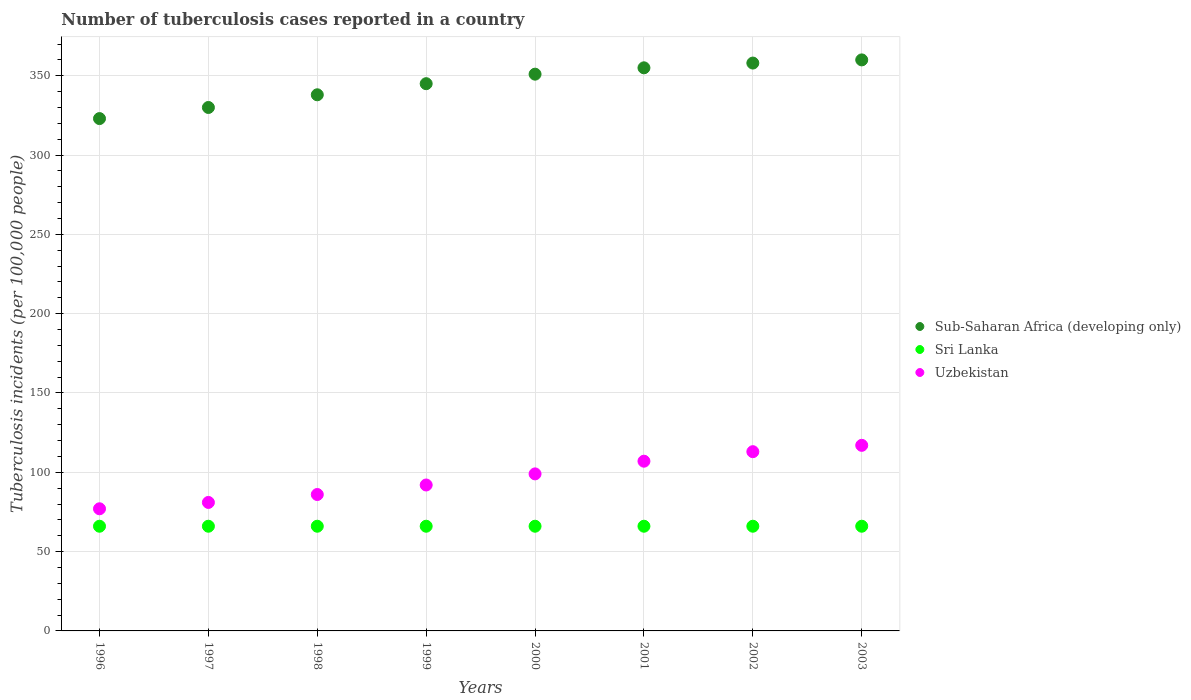How many different coloured dotlines are there?
Your response must be concise. 3. What is the number of tuberculosis cases reported in in Sub-Saharan Africa (developing only) in 2003?
Ensure brevity in your answer.  360. Across all years, what is the maximum number of tuberculosis cases reported in in Uzbekistan?
Provide a short and direct response. 117. Across all years, what is the minimum number of tuberculosis cases reported in in Uzbekistan?
Provide a short and direct response. 77. In which year was the number of tuberculosis cases reported in in Sri Lanka maximum?
Your answer should be compact. 1996. In which year was the number of tuberculosis cases reported in in Sub-Saharan Africa (developing only) minimum?
Offer a very short reply. 1996. What is the total number of tuberculosis cases reported in in Sub-Saharan Africa (developing only) in the graph?
Your answer should be very brief. 2760. What is the difference between the number of tuberculosis cases reported in in Uzbekistan in 1997 and the number of tuberculosis cases reported in in Sri Lanka in 2000?
Ensure brevity in your answer.  15. What is the average number of tuberculosis cases reported in in Sub-Saharan Africa (developing only) per year?
Offer a terse response. 345. In the year 1999, what is the difference between the number of tuberculosis cases reported in in Uzbekistan and number of tuberculosis cases reported in in Sri Lanka?
Give a very brief answer. 26. In how many years, is the number of tuberculosis cases reported in in Uzbekistan greater than 230?
Provide a succinct answer. 0. Is the number of tuberculosis cases reported in in Sri Lanka in 1997 less than that in 2001?
Provide a short and direct response. No. Is the difference between the number of tuberculosis cases reported in in Uzbekistan in 2001 and 2003 greater than the difference between the number of tuberculosis cases reported in in Sri Lanka in 2001 and 2003?
Offer a very short reply. No. What is the difference between the highest and the lowest number of tuberculosis cases reported in in Sub-Saharan Africa (developing only)?
Your answer should be compact. 37. In how many years, is the number of tuberculosis cases reported in in Sri Lanka greater than the average number of tuberculosis cases reported in in Sri Lanka taken over all years?
Your answer should be very brief. 0. Is the sum of the number of tuberculosis cases reported in in Sri Lanka in 1998 and 2000 greater than the maximum number of tuberculosis cases reported in in Uzbekistan across all years?
Provide a short and direct response. Yes. Is it the case that in every year, the sum of the number of tuberculosis cases reported in in Sub-Saharan Africa (developing only) and number of tuberculosis cases reported in in Sri Lanka  is greater than the number of tuberculosis cases reported in in Uzbekistan?
Offer a very short reply. Yes. Is the number of tuberculosis cases reported in in Sub-Saharan Africa (developing only) strictly greater than the number of tuberculosis cases reported in in Uzbekistan over the years?
Provide a succinct answer. Yes. Is the number of tuberculosis cases reported in in Sri Lanka strictly less than the number of tuberculosis cases reported in in Uzbekistan over the years?
Your response must be concise. Yes. How many years are there in the graph?
Ensure brevity in your answer.  8. Does the graph contain any zero values?
Your response must be concise. No. Does the graph contain grids?
Offer a terse response. Yes. How many legend labels are there?
Your answer should be very brief. 3. What is the title of the graph?
Offer a terse response. Number of tuberculosis cases reported in a country. What is the label or title of the Y-axis?
Your response must be concise. Tuberculosis incidents (per 100,0 people). What is the Tuberculosis incidents (per 100,000 people) in Sub-Saharan Africa (developing only) in 1996?
Keep it short and to the point. 323. What is the Tuberculosis incidents (per 100,000 people) in Sri Lanka in 1996?
Your response must be concise. 66. What is the Tuberculosis incidents (per 100,000 people) in Sub-Saharan Africa (developing only) in 1997?
Offer a terse response. 330. What is the Tuberculosis incidents (per 100,000 people) in Sri Lanka in 1997?
Provide a short and direct response. 66. What is the Tuberculosis incidents (per 100,000 people) in Sub-Saharan Africa (developing only) in 1998?
Keep it short and to the point. 338. What is the Tuberculosis incidents (per 100,000 people) of Sri Lanka in 1998?
Ensure brevity in your answer.  66. What is the Tuberculosis incidents (per 100,000 people) in Sub-Saharan Africa (developing only) in 1999?
Give a very brief answer. 345. What is the Tuberculosis incidents (per 100,000 people) of Sri Lanka in 1999?
Offer a very short reply. 66. What is the Tuberculosis incidents (per 100,000 people) of Uzbekistan in 1999?
Your answer should be compact. 92. What is the Tuberculosis incidents (per 100,000 people) of Sub-Saharan Africa (developing only) in 2000?
Offer a very short reply. 351. What is the Tuberculosis incidents (per 100,000 people) of Uzbekistan in 2000?
Your answer should be very brief. 99. What is the Tuberculosis incidents (per 100,000 people) of Sub-Saharan Africa (developing only) in 2001?
Give a very brief answer. 355. What is the Tuberculosis incidents (per 100,000 people) of Sri Lanka in 2001?
Provide a succinct answer. 66. What is the Tuberculosis incidents (per 100,000 people) in Uzbekistan in 2001?
Provide a short and direct response. 107. What is the Tuberculosis incidents (per 100,000 people) in Sub-Saharan Africa (developing only) in 2002?
Offer a terse response. 358. What is the Tuberculosis incidents (per 100,000 people) of Sri Lanka in 2002?
Ensure brevity in your answer.  66. What is the Tuberculosis incidents (per 100,000 people) of Uzbekistan in 2002?
Ensure brevity in your answer.  113. What is the Tuberculosis incidents (per 100,000 people) of Sub-Saharan Africa (developing only) in 2003?
Your answer should be compact. 360. What is the Tuberculosis incidents (per 100,000 people) in Uzbekistan in 2003?
Keep it short and to the point. 117. Across all years, what is the maximum Tuberculosis incidents (per 100,000 people) in Sub-Saharan Africa (developing only)?
Give a very brief answer. 360. Across all years, what is the maximum Tuberculosis incidents (per 100,000 people) of Uzbekistan?
Your answer should be very brief. 117. Across all years, what is the minimum Tuberculosis incidents (per 100,000 people) of Sub-Saharan Africa (developing only)?
Provide a succinct answer. 323. What is the total Tuberculosis incidents (per 100,000 people) in Sub-Saharan Africa (developing only) in the graph?
Offer a very short reply. 2760. What is the total Tuberculosis incidents (per 100,000 people) of Sri Lanka in the graph?
Ensure brevity in your answer.  528. What is the total Tuberculosis incidents (per 100,000 people) in Uzbekistan in the graph?
Your answer should be very brief. 772. What is the difference between the Tuberculosis incidents (per 100,000 people) in Uzbekistan in 1996 and that in 1997?
Your response must be concise. -4. What is the difference between the Tuberculosis incidents (per 100,000 people) of Sub-Saharan Africa (developing only) in 1996 and that in 1998?
Offer a very short reply. -15. What is the difference between the Tuberculosis incidents (per 100,000 people) of Sub-Saharan Africa (developing only) in 1996 and that in 1999?
Offer a very short reply. -22. What is the difference between the Tuberculosis incidents (per 100,000 people) of Uzbekistan in 1996 and that in 1999?
Your response must be concise. -15. What is the difference between the Tuberculosis incidents (per 100,000 people) of Sub-Saharan Africa (developing only) in 1996 and that in 2000?
Provide a short and direct response. -28. What is the difference between the Tuberculosis incidents (per 100,000 people) in Sri Lanka in 1996 and that in 2000?
Your response must be concise. 0. What is the difference between the Tuberculosis incidents (per 100,000 people) of Sub-Saharan Africa (developing only) in 1996 and that in 2001?
Provide a short and direct response. -32. What is the difference between the Tuberculosis incidents (per 100,000 people) in Sub-Saharan Africa (developing only) in 1996 and that in 2002?
Your answer should be very brief. -35. What is the difference between the Tuberculosis incidents (per 100,000 people) in Uzbekistan in 1996 and that in 2002?
Ensure brevity in your answer.  -36. What is the difference between the Tuberculosis incidents (per 100,000 people) of Sub-Saharan Africa (developing only) in 1996 and that in 2003?
Your answer should be compact. -37. What is the difference between the Tuberculosis incidents (per 100,000 people) of Sri Lanka in 1996 and that in 2003?
Your answer should be compact. 0. What is the difference between the Tuberculosis incidents (per 100,000 people) of Sub-Saharan Africa (developing only) in 1997 and that in 1998?
Your answer should be compact. -8. What is the difference between the Tuberculosis incidents (per 100,000 people) in Sri Lanka in 1997 and that in 1998?
Ensure brevity in your answer.  0. What is the difference between the Tuberculosis incidents (per 100,000 people) in Uzbekistan in 1997 and that in 1998?
Offer a very short reply. -5. What is the difference between the Tuberculosis incidents (per 100,000 people) in Sub-Saharan Africa (developing only) in 1997 and that in 1999?
Your response must be concise. -15. What is the difference between the Tuberculosis incidents (per 100,000 people) in Sri Lanka in 1997 and that in 1999?
Your answer should be compact. 0. What is the difference between the Tuberculosis incidents (per 100,000 people) of Uzbekistan in 1997 and that in 1999?
Provide a succinct answer. -11. What is the difference between the Tuberculosis incidents (per 100,000 people) of Sri Lanka in 1997 and that in 2000?
Give a very brief answer. 0. What is the difference between the Tuberculosis incidents (per 100,000 people) of Uzbekistan in 1997 and that in 2000?
Give a very brief answer. -18. What is the difference between the Tuberculosis incidents (per 100,000 people) of Sub-Saharan Africa (developing only) in 1997 and that in 2001?
Ensure brevity in your answer.  -25. What is the difference between the Tuberculosis incidents (per 100,000 people) in Sri Lanka in 1997 and that in 2001?
Provide a short and direct response. 0. What is the difference between the Tuberculosis incidents (per 100,000 people) in Sri Lanka in 1997 and that in 2002?
Make the answer very short. 0. What is the difference between the Tuberculosis incidents (per 100,000 people) in Uzbekistan in 1997 and that in 2002?
Provide a short and direct response. -32. What is the difference between the Tuberculosis incidents (per 100,000 people) of Sri Lanka in 1997 and that in 2003?
Make the answer very short. 0. What is the difference between the Tuberculosis incidents (per 100,000 people) in Uzbekistan in 1997 and that in 2003?
Your answer should be very brief. -36. What is the difference between the Tuberculosis incidents (per 100,000 people) in Sub-Saharan Africa (developing only) in 1998 and that in 1999?
Make the answer very short. -7. What is the difference between the Tuberculosis incidents (per 100,000 people) of Sri Lanka in 1998 and that in 1999?
Offer a terse response. 0. What is the difference between the Tuberculosis incidents (per 100,000 people) in Sub-Saharan Africa (developing only) in 1998 and that in 2000?
Offer a very short reply. -13. What is the difference between the Tuberculosis incidents (per 100,000 people) of Uzbekistan in 1998 and that in 2000?
Your response must be concise. -13. What is the difference between the Tuberculosis incidents (per 100,000 people) in Sub-Saharan Africa (developing only) in 1998 and that in 2001?
Offer a very short reply. -17. What is the difference between the Tuberculosis incidents (per 100,000 people) of Sri Lanka in 1998 and that in 2001?
Your response must be concise. 0. What is the difference between the Tuberculosis incidents (per 100,000 people) of Sub-Saharan Africa (developing only) in 1998 and that in 2002?
Offer a terse response. -20. What is the difference between the Tuberculosis incidents (per 100,000 people) in Uzbekistan in 1998 and that in 2002?
Provide a short and direct response. -27. What is the difference between the Tuberculosis incidents (per 100,000 people) in Sri Lanka in 1998 and that in 2003?
Offer a very short reply. 0. What is the difference between the Tuberculosis incidents (per 100,000 people) of Uzbekistan in 1998 and that in 2003?
Keep it short and to the point. -31. What is the difference between the Tuberculosis incidents (per 100,000 people) in Sub-Saharan Africa (developing only) in 1999 and that in 2000?
Offer a terse response. -6. What is the difference between the Tuberculosis incidents (per 100,000 people) of Uzbekistan in 1999 and that in 2002?
Your answer should be very brief. -21. What is the difference between the Tuberculosis incidents (per 100,000 people) in Sri Lanka in 1999 and that in 2003?
Your answer should be compact. 0. What is the difference between the Tuberculosis incidents (per 100,000 people) in Sub-Saharan Africa (developing only) in 2000 and that in 2001?
Give a very brief answer. -4. What is the difference between the Tuberculosis incidents (per 100,000 people) of Sub-Saharan Africa (developing only) in 2000 and that in 2002?
Keep it short and to the point. -7. What is the difference between the Tuberculosis incidents (per 100,000 people) in Uzbekistan in 2000 and that in 2002?
Your answer should be compact. -14. What is the difference between the Tuberculosis incidents (per 100,000 people) of Uzbekistan in 2000 and that in 2003?
Ensure brevity in your answer.  -18. What is the difference between the Tuberculosis incidents (per 100,000 people) in Sub-Saharan Africa (developing only) in 2001 and that in 2002?
Your answer should be compact. -3. What is the difference between the Tuberculosis incidents (per 100,000 people) of Sri Lanka in 2001 and that in 2002?
Your response must be concise. 0. What is the difference between the Tuberculosis incidents (per 100,000 people) in Sri Lanka in 2001 and that in 2003?
Ensure brevity in your answer.  0. What is the difference between the Tuberculosis incidents (per 100,000 people) in Uzbekistan in 2001 and that in 2003?
Your answer should be compact. -10. What is the difference between the Tuberculosis incidents (per 100,000 people) in Sub-Saharan Africa (developing only) in 1996 and the Tuberculosis incidents (per 100,000 people) in Sri Lanka in 1997?
Your answer should be very brief. 257. What is the difference between the Tuberculosis incidents (per 100,000 people) in Sub-Saharan Africa (developing only) in 1996 and the Tuberculosis incidents (per 100,000 people) in Uzbekistan in 1997?
Offer a terse response. 242. What is the difference between the Tuberculosis incidents (per 100,000 people) of Sri Lanka in 1996 and the Tuberculosis incidents (per 100,000 people) of Uzbekistan in 1997?
Keep it short and to the point. -15. What is the difference between the Tuberculosis incidents (per 100,000 people) in Sub-Saharan Africa (developing only) in 1996 and the Tuberculosis incidents (per 100,000 people) in Sri Lanka in 1998?
Offer a very short reply. 257. What is the difference between the Tuberculosis incidents (per 100,000 people) in Sub-Saharan Africa (developing only) in 1996 and the Tuberculosis incidents (per 100,000 people) in Uzbekistan in 1998?
Your response must be concise. 237. What is the difference between the Tuberculosis incidents (per 100,000 people) in Sub-Saharan Africa (developing only) in 1996 and the Tuberculosis incidents (per 100,000 people) in Sri Lanka in 1999?
Offer a terse response. 257. What is the difference between the Tuberculosis incidents (per 100,000 people) of Sub-Saharan Africa (developing only) in 1996 and the Tuberculosis incidents (per 100,000 people) of Uzbekistan in 1999?
Your answer should be very brief. 231. What is the difference between the Tuberculosis incidents (per 100,000 people) of Sub-Saharan Africa (developing only) in 1996 and the Tuberculosis incidents (per 100,000 people) of Sri Lanka in 2000?
Your answer should be compact. 257. What is the difference between the Tuberculosis incidents (per 100,000 people) of Sub-Saharan Africa (developing only) in 1996 and the Tuberculosis incidents (per 100,000 people) of Uzbekistan in 2000?
Your response must be concise. 224. What is the difference between the Tuberculosis incidents (per 100,000 people) of Sri Lanka in 1996 and the Tuberculosis incidents (per 100,000 people) of Uzbekistan in 2000?
Offer a very short reply. -33. What is the difference between the Tuberculosis incidents (per 100,000 people) in Sub-Saharan Africa (developing only) in 1996 and the Tuberculosis incidents (per 100,000 people) in Sri Lanka in 2001?
Ensure brevity in your answer.  257. What is the difference between the Tuberculosis incidents (per 100,000 people) in Sub-Saharan Africa (developing only) in 1996 and the Tuberculosis incidents (per 100,000 people) in Uzbekistan in 2001?
Provide a succinct answer. 216. What is the difference between the Tuberculosis incidents (per 100,000 people) of Sri Lanka in 1996 and the Tuberculosis incidents (per 100,000 people) of Uzbekistan in 2001?
Offer a terse response. -41. What is the difference between the Tuberculosis incidents (per 100,000 people) of Sub-Saharan Africa (developing only) in 1996 and the Tuberculosis incidents (per 100,000 people) of Sri Lanka in 2002?
Provide a succinct answer. 257. What is the difference between the Tuberculosis incidents (per 100,000 people) of Sub-Saharan Africa (developing only) in 1996 and the Tuberculosis incidents (per 100,000 people) of Uzbekistan in 2002?
Your answer should be compact. 210. What is the difference between the Tuberculosis incidents (per 100,000 people) in Sri Lanka in 1996 and the Tuberculosis incidents (per 100,000 people) in Uzbekistan in 2002?
Give a very brief answer. -47. What is the difference between the Tuberculosis incidents (per 100,000 people) of Sub-Saharan Africa (developing only) in 1996 and the Tuberculosis incidents (per 100,000 people) of Sri Lanka in 2003?
Offer a very short reply. 257. What is the difference between the Tuberculosis incidents (per 100,000 people) of Sub-Saharan Africa (developing only) in 1996 and the Tuberculosis incidents (per 100,000 people) of Uzbekistan in 2003?
Give a very brief answer. 206. What is the difference between the Tuberculosis incidents (per 100,000 people) of Sri Lanka in 1996 and the Tuberculosis incidents (per 100,000 people) of Uzbekistan in 2003?
Your answer should be very brief. -51. What is the difference between the Tuberculosis incidents (per 100,000 people) in Sub-Saharan Africa (developing only) in 1997 and the Tuberculosis incidents (per 100,000 people) in Sri Lanka in 1998?
Ensure brevity in your answer.  264. What is the difference between the Tuberculosis incidents (per 100,000 people) of Sub-Saharan Africa (developing only) in 1997 and the Tuberculosis incidents (per 100,000 people) of Uzbekistan in 1998?
Keep it short and to the point. 244. What is the difference between the Tuberculosis incidents (per 100,000 people) of Sri Lanka in 1997 and the Tuberculosis incidents (per 100,000 people) of Uzbekistan in 1998?
Offer a very short reply. -20. What is the difference between the Tuberculosis incidents (per 100,000 people) of Sub-Saharan Africa (developing only) in 1997 and the Tuberculosis incidents (per 100,000 people) of Sri Lanka in 1999?
Provide a succinct answer. 264. What is the difference between the Tuberculosis incidents (per 100,000 people) of Sub-Saharan Africa (developing only) in 1997 and the Tuberculosis incidents (per 100,000 people) of Uzbekistan in 1999?
Offer a terse response. 238. What is the difference between the Tuberculosis incidents (per 100,000 people) of Sub-Saharan Africa (developing only) in 1997 and the Tuberculosis incidents (per 100,000 people) of Sri Lanka in 2000?
Your answer should be compact. 264. What is the difference between the Tuberculosis incidents (per 100,000 people) in Sub-Saharan Africa (developing only) in 1997 and the Tuberculosis incidents (per 100,000 people) in Uzbekistan in 2000?
Make the answer very short. 231. What is the difference between the Tuberculosis incidents (per 100,000 people) of Sri Lanka in 1997 and the Tuberculosis incidents (per 100,000 people) of Uzbekistan in 2000?
Give a very brief answer. -33. What is the difference between the Tuberculosis incidents (per 100,000 people) of Sub-Saharan Africa (developing only) in 1997 and the Tuberculosis incidents (per 100,000 people) of Sri Lanka in 2001?
Your answer should be compact. 264. What is the difference between the Tuberculosis incidents (per 100,000 people) in Sub-Saharan Africa (developing only) in 1997 and the Tuberculosis incidents (per 100,000 people) in Uzbekistan in 2001?
Provide a succinct answer. 223. What is the difference between the Tuberculosis incidents (per 100,000 people) of Sri Lanka in 1997 and the Tuberculosis incidents (per 100,000 people) of Uzbekistan in 2001?
Keep it short and to the point. -41. What is the difference between the Tuberculosis incidents (per 100,000 people) in Sub-Saharan Africa (developing only) in 1997 and the Tuberculosis incidents (per 100,000 people) in Sri Lanka in 2002?
Provide a succinct answer. 264. What is the difference between the Tuberculosis incidents (per 100,000 people) in Sub-Saharan Africa (developing only) in 1997 and the Tuberculosis incidents (per 100,000 people) in Uzbekistan in 2002?
Give a very brief answer. 217. What is the difference between the Tuberculosis incidents (per 100,000 people) in Sri Lanka in 1997 and the Tuberculosis incidents (per 100,000 people) in Uzbekistan in 2002?
Your answer should be very brief. -47. What is the difference between the Tuberculosis incidents (per 100,000 people) of Sub-Saharan Africa (developing only) in 1997 and the Tuberculosis incidents (per 100,000 people) of Sri Lanka in 2003?
Your answer should be compact. 264. What is the difference between the Tuberculosis incidents (per 100,000 people) in Sub-Saharan Africa (developing only) in 1997 and the Tuberculosis incidents (per 100,000 people) in Uzbekistan in 2003?
Ensure brevity in your answer.  213. What is the difference between the Tuberculosis incidents (per 100,000 people) of Sri Lanka in 1997 and the Tuberculosis incidents (per 100,000 people) of Uzbekistan in 2003?
Give a very brief answer. -51. What is the difference between the Tuberculosis incidents (per 100,000 people) in Sub-Saharan Africa (developing only) in 1998 and the Tuberculosis incidents (per 100,000 people) in Sri Lanka in 1999?
Your answer should be very brief. 272. What is the difference between the Tuberculosis incidents (per 100,000 people) in Sub-Saharan Africa (developing only) in 1998 and the Tuberculosis incidents (per 100,000 people) in Uzbekistan in 1999?
Your answer should be very brief. 246. What is the difference between the Tuberculosis incidents (per 100,000 people) of Sri Lanka in 1998 and the Tuberculosis incidents (per 100,000 people) of Uzbekistan in 1999?
Provide a short and direct response. -26. What is the difference between the Tuberculosis incidents (per 100,000 people) of Sub-Saharan Africa (developing only) in 1998 and the Tuberculosis incidents (per 100,000 people) of Sri Lanka in 2000?
Give a very brief answer. 272. What is the difference between the Tuberculosis incidents (per 100,000 people) in Sub-Saharan Africa (developing only) in 1998 and the Tuberculosis incidents (per 100,000 people) in Uzbekistan in 2000?
Your answer should be compact. 239. What is the difference between the Tuberculosis incidents (per 100,000 people) in Sri Lanka in 1998 and the Tuberculosis incidents (per 100,000 people) in Uzbekistan in 2000?
Your answer should be very brief. -33. What is the difference between the Tuberculosis incidents (per 100,000 people) in Sub-Saharan Africa (developing only) in 1998 and the Tuberculosis incidents (per 100,000 people) in Sri Lanka in 2001?
Give a very brief answer. 272. What is the difference between the Tuberculosis incidents (per 100,000 people) in Sub-Saharan Africa (developing only) in 1998 and the Tuberculosis incidents (per 100,000 people) in Uzbekistan in 2001?
Offer a terse response. 231. What is the difference between the Tuberculosis incidents (per 100,000 people) of Sri Lanka in 1998 and the Tuberculosis incidents (per 100,000 people) of Uzbekistan in 2001?
Your response must be concise. -41. What is the difference between the Tuberculosis incidents (per 100,000 people) of Sub-Saharan Africa (developing only) in 1998 and the Tuberculosis incidents (per 100,000 people) of Sri Lanka in 2002?
Your response must be concise. 272. What is the difference between the Tuberculosis incidents (per 100,000 people) in Sub-Saharan Africa (developing only) in 1998 and the Tuberculosis incidents (per 100,000 people) in Uzbekistan in 2002?
Your answer should be very brief. 225. What is the difference between the Tuberculosis incidents (per 100,000 people) in Sri Lanka in 1998 and the Tuberculosis incidents (per 100,000 people) in Uzbekistan in 2002?
Provide a short and direct response. -47. What is the difference between the Tuberculosis incidents (per 100,000 people) in Sub-Saharan Africa (developing only) in 1998 and the Tuberculosis incidents (per 100,000 people) in Sri Lanka in 2003?
Provide a short and direct response. 272. What is the difference between the Tuberculosis incidents (per 100,000 people) in Sub-Saharan Africa (developing only) in 1998 and the Tuberculosis incidents (per 100,000 people) in Uzbekistan in 2003?
Give a very brief answer. 221. What is the difference between the Tuberculosis incidents (per 100,000 people) in Sri Lanka in 1998 and the Tuberculosis incidents (per 100,000 people) in Uzbekistan in 2003?
Your response must be concise. -51. What is the difference between the Tuberculosis incidents (per 100,000 people) in Sub-Saharan Africa (developing only) in 1999 and the Tuberculosis incidents (per 100,000 people) in Sri Lanka in 2000?
Offer a terse response. 279. What is the difference between the Tuberculosis incidents (per 100,000 people) in Sub-Saharan Africa (developing only) in 1999 and the Tuberculosis incidents (per 100,000 people) in Uzbekistan in 2000?
Your answer should be very brief. 246. What is the difference between the Tuberculosis incidents (per 100,000 people) in Sri Lanka in 1999 and the Tuberculosis incidents (per 100,000 people) in Uzbekistan in 2000?
Ensure brevity in your answer.  -33. What is the difference between the Tuberculosis incidents (per 100,000 people) of Sub-Saharan Africa (developing only) in 1999 and the Tuberculosis incidents (per 100,000 people) of Sri Lanka in 2001?
Your response must be concise. 279. What is the difference between the Tuberculosis incidents (per 100,000 people) of Sub-Saharan Africa (developing only) in 1999 and the Tuberculosis incidents (per 100,000 people) of Uzbekistan in 2001?
Ensure brevity in your answer.  238. What is the difference between the Tuberculosis incidents (per 100,000 people) of Sri Lanka in 1999 and the Tuberculosis incidents (per 100,000 people) of Uzbekistan in 2001?
Your response must be concise. -41. What is the difference between the Tuberculosis incidents (per 100,000 people) in Sub-Saharan Africa (developing only) in 1999 and the Tuberculosis incidents (per 100,000 people) in Sri Lanka in 2002?
Ensure brevity in your answer.  279. What is the difference between the Tuberculosis incidents (per 100,000 people) of Sub-Saharan Africa (developing only) in 1999 and the Tuberculosis incidents (per 100,000 people) of Uzbekistan in 2002?
Your answer should be very brief. 232. What is the difference between the Tuberculosis incidents (per 100,000 people) in Sri Lanka in 1999 and the Tuberculosis incidents (per 100,000 people) in Uzbekistan in 2002?
Offer a very short reply. -47. What is the difference between the Tuberculosis incidents (per 100,000 people) in Sub-Saharan Africa (developing only) in 1999 and the Tuberculosis incidents (per 100,000 people) in Sri Lanka in 2003?
Your answer should be very brief. 279. What is the difference between the Tuberculosis incidents (per 100,000 people) of Sub-Saharan Africa (developing only) in 1999 and the Tuberculosis incidents (per 100,000 people) of Uzbekistan in 2003?
Give a very brief answer. 228. What is the difference between the Tuberculosis incidents (per 100,000 people) in Sri Lanka in 1999 and the Tuberculosis incidents (per 100,000 people) in Uzbekistan in 2003?
Give a very brief answer. -51. What is the difference between the Tuberculosis incidents (per 100,000 people) of Sub-Saharan Africa (developing only) in 2000 and the Tuberculosis incidents (per 100,000 people) of Sri Lanka in 2001?
Offer a terse response. 285. What is the difference between the Tuberculosis incidents (per 100,000 people) in Sub-Saharan Africa (developing only) in 2000 and the Tuberculosis incidents (per 100,000 people) in Uzbekistan in 2001?
Offer a terse response. 244. What is the difference between the Tuberculosis incidents (per 100,000 people) in Sri Lanka in 2000 and the Tuberculosis incidents (per 100,000 people) in Uzbekistan in 2001?
Offer a terse response. -41. What is the difference between the Tuberculosis incidents (per 100,000 people) in Sub-Saharan Africa (developing only) in 2000 and the Tuberculosis incidents (per 100,000 people) in Sri Lanka in 2002?
Provide a succinct answer. 285. What is the difference between the Tuberculosis incidents (per 100,000 people) in Sub-Saharan Africa (developing only) in 2000 and the Tuberculosis incidents (per 100,000 people) in Uzbekistan in 2002?
Ensure brevity in your answer.  238. What is the difference between the Tuberculosis incidents (per 100,000 people) in Sri Lanka in 2000 and the Tuberculosis incidents (per 100,000 people) in Uzbekistan in 2002?
Your answer should be compact. -47. What is the difference between the Tuberculosis incidents (per 100,000 people) of Sub-Saharan Africa (developing only) in 2000 and the Tuberculosis incidents (per 100,000 people) of Sri Lanka in 2003?
Your answer should be very brief. 285. What is the difference between the Tuberculosis incidents (per 100,000 people) in Sub-Saharan Africa (developing only) in 2000 and the Tuberculosis incidents (per 100,000 people) in Uzbekistan in 2003?
Keep it short and to the point. 234. What is the difference between the Tuberculosis incidents (per 100,000 people) of Sri Lanka in 2000 and the Tuberculosis incidents (per 100,000 people) of Uzbekistan in 2003?
Your response must be concise. -51. What is the difference between the Tuberculosis incidents (per 100,000 people) in Sub-Saharan Africa (developing only) in 2001 and the Tuberculosis incidents (per 100,000 people) in Sri Lanka in 2002?
Your response must be concise. 289. What is the difference between the Tuberculosis incidents (per 100,000 people) of Sub-Saharan Africa (developing only) in 2001 and the Tuberculosis incidents (per 100,000 people) of Uzbekistan in 2002?
Ensure brevity in your answer.  242. What is the difference between the Tuberculosis incidents (per 100,000 people) in Sri Lanka in 2001 and the Tuberculosis incidents (per 100,000 people) in Uzbekistan in 2002?
Provide a succinct answer. -47. What is the difference between the Tuberculosis incidents (per 100,000 people) of Sub-Saharan Africa (developing only) in 2001 and the Tuberculosis incidents (per 100,000 people) of Sri Lanka in 2003?
Ensure brevity in your answer.  289. What is the difference between the Tuberculosis incidents (per 100,000 people) in Sub-Saharan Africa (developing only) in 2001 and the Tuberculosis incidents (per 100,000 people) in Uzbekistan in 2003?
Offer a very short reply. 238. What is the difference between the Tuberculosis incidents (per 100,000 people) in Sri Lanka in 2001 and the Tuberculosis incidents (per 100,000 people) in Uzbekistan in 2003?
Offer a terse response. -51. What is the difference between the Tuberculosis incidents (per 100,000 people) of Sub-Saharan Africa (developing only) in 2002 and the Tuberculosis incidents (per 100,000 people) of Sri Lanka in 2003?
Your answer should be compact. 292. What is the difference between the Tuberculosis incidents (per 100,000 people) of Sub-Saharan Africa (developing only) in 2002 and the Tuberculosis incidents (per 100,000 people) of Uzbekistan in 2003?
Ensure brevity in your answer.  241. What is the difference between the Tuberculosis incidents (per 100,000 people) in Sri Lanka in 2002 and the Tuberculosis incidents (per 100,000 people) in Uzbekistan in 2003?
Give a very brief answer. -51. What is the average Tuberculosis incidents (per 100,000 people) of Sub-Saharan Africa (developing only) per year?
Ensure brevity in your answer.  345. What is the average Tuberculosis incidents (per 100,000 people) of Sri Lanka per year?
Your answer should be very brief. 66. What is the average Tuberculosis incidents (per 100,000 people) of Uzbekistan per year?
Your answer should be very brief. 96.5. In the year 1996, what is the difference between the Tuberculosis incidents (per 100,000 people) in Sub-Saharan Africa (developing only) and Tuberculosis incidents (per 100,000 people) in Sri Lanka?
Your answer should be very brief. 257. In the year 1996, what is the difference between the Tuberculosis incidents (per 100,000 people) of Sub-Saharan Africa (developing only) and Tuberculosis incidents (per 100,000 people) of Uzbekistan?
Your answer should be compact. 246. In the year 1996, what is the difference between the Tuberculosis incidents (per 100,000 people) in Sri Lanka and Tuberculosis incidents (per 100,000 people) in Uzbekistan?
Make the answer very short. -11. In the year 1997, what is the difference between the Tuberculosis incidents (per 100,000 people) of Sub-Saharan Africa (developing only) and Tuberculosis incidents (per 100,000 people) of Sri Lanka?
Provide a succinct answer. 264. In the year 1997, what is the difference between the Tuberculosis incidents (per 100,000 people) in Sub-Saharan Africa (developing only) and Tuberculosis incidents (per 100,000 people) in Uzbekistan?
Provide a short and direct response. 249. In the year 1998, what is the difference between the Tuberculosis incidents (per 100,000 people) in Sub-Saharan Africa (developing only) and Tuberculosis incidents (per 100,000 people) in Sri Lanka?
Offer a very short reply. 272. In the year 1998, what is the difference between the Tuberculosis incidents (per 100,000 people) of Sub-Saharan Africa (developing only) and Tuberculosis incidents (per 100,000 people) of Uzbekistan?
Offer a terse response. 252. In the year 1998, what is the difference between the Tuberculosis incidents (per 100,000 people) in Sri Lanka and Tuberculosis incidents (per 100,000 people) in Uzbekistan?
Give a very brief answer. -20. In the year 1999, what is the difference between the Tuberculosis incidents (per 100,000 people) of Sub-Saharan Africa (developing only) and Tuberculosis incidents (per 100,000 people) of Sri Lanka?
Make the answer very short. 279. In the year 1999, what is the difference between the Tuberculosis incidents (per 100,000 people) of Sub-Saharan Africa (developing only) and Tuberculosis incidents (per 100,000 people) of Uzbekistan?
Your response must be concise. 253. In the year 1999, what is the difference between the Tuberculosis incidents (per 100,000 people) of Sri Lanka and Tuberculosis incidents (per 100,000 people) of Uzbekistan?
Give a very brief answer. -26. In the year 2000, what is the difference between the Tuberculosis incidents (per 100,000 people) of Sub-Saharan Africa (developing only) and Tuberculosis incidents (per 100,000 people) of Sri Lanka?
Offer a very short reply. 285. In the year 2000, what is the difference between the Tuberculosis incidents (per 100,000 people) of Sub-Saharan Africa (developing only) and Tuberculosis incidents (per 100,000 people) of Uzbekistan?
Your answer should be very brief. 252. In the year 2000, what is the difference between the Tuberculosis incidents (per 100,000 people) in Sri Lanka and Tuberculosis incidents (per 100,000 people) in Uzbekistan?
Keep it short and to the point. -33. In the year 2001, what is the difference between the Tuberculosis incidents (per 100,000 people) of Sub-Saharan Africa (developing only) and Tuberculosis incidents (per 100,000 people) of Sri Lanka?
Keep it short and to the point. 289. In the year 2001, what is the difference between the Tuberculosis incidents (per 100,000 people) in Sub-Saharan Africa (developing only) and Tuberculosis incidents (per 100,000 people) in Uzbekistan?
Your answer should be compact. 248. In the year 2001, what is the difference between the Tuberculosis incidents (per 100,000 people) of Sri Lanka and Tuberculosis incidents (per 100,000 people) of Uzbekistan?
Ensure brevity in your answer.  -41. In the year 2002, what is the difference between the Tuberculosis incidents (per 100,000 people) in Sub-Saharan Africa (developing only) and Tuberculosis incidents (per 100,000 people) in Sri Lanka?
Offer a terse response. 292. In the year 2002, what is the difference between the Tuberculosis incidents (per 100,000 people) in Sub-Saharan Africa (developing only) and Tuberculosis incidents (per 100,000 people) in Uzbekistan?
Make the answer very short. 245. In the year 2002, what is the difference between the Tuberculosis incidents (per 100,000 people) in Sri Lanka and Tuberculosis incidents (per 100,000 people) in Uzbekistan?
Provide a succinct answer. -47. In the year 2003, what is the difference between the Tuberculosis incidents (per 100,000 people) of Sub-Saharan Africa (developing only) and Tuberculosis incidents (per 100,000 people) of Sri Lanka?
Give a very brief answer. 294. In the year 2003, what is the difference between the Tuberculosis incidents (per 100,000 people) of Sub-Saharan Africa (developing only) and Tuberculosis incidents (per 100,000 people) of Uzbekistan?
Make the answer very short. 243. In the year 2003, what is the difference between the Tuberculosis incidents (per 100,000 people) of Sri Lanka and Tuberculosis incidents (per 100,000 people) of Uzbekistan?
Your answer should be very brief. -51. What is the ratio of the Tuberculosis incidents (per 100,000 people) in Sub-Saharan Africa (developing only) in 1996 to that in 1997?
Ensure brevity in your answer.  0.98. What is the ratio of the Tuberculosis incidents (per 100,000 people) in Uzbekistan in 1996 to that in 1997?
Make the answer very short. 0.95. What is the ratio of the Tuberculosis incidents (per 100,000 people) of Sub-Saharan Africa (developing only) in 1996 to that in 1998?
Provide a succinct answer. 0.96. What is the ratio of the Tuberculosis incidents (per 100,000 people) in Sri Lanka in 1996 to that in 1998?
Keep it short and to the point. 1. What is the ratio of the Tuberculosis incidents (per 100,000 people) in Uzbekistan in 1996 to that in 1998?
Offer a terse response. 0.9. What is the ratio of the Tuberculosis incidents (per 100,000 people) of Sub-Saharan Africa (developing only) in 1996 to that in 1999?
Your answer should be very brief. 0.94. What is the ratio of the Tuberculosis incidents (per 100,000 people) in Uzbekistan in 1996 to that in 1999?
Offer a very short reply. 0.84. What is the ratio of the Tuberculosis incidents (per 100,000 people) of Sub-Saharan Africa (developing only) in 1996 to that in 2000?
Ensure brevity in your answer.  0.92. What is the ratio of the Tuberculosis incidents (per 100,000 people) of Sub-Saharan Africa (developing only) in 1996 to that in 2001?
Your response must be concise. 0.91. What is the ratio of the Tuberculosis incidents (per 100,000 people) in Uzbekistan in 1996 to that in 2001?
Your response must be concise. 0.72. What is the ratio of the Tuberculosis incidents (per 100,000 people) of Sub-Saharan Africa (developing only) in 1996 to that in 2002?
Provide a short and direct response. 0.9. What is the ratio of the Tuberculosis incidents (per 100,000 people) of Uzbekistan in 1996 to that in 2002?
Offer a very short reply. 0.68. What is the ratio of the Tuberculosis incidents (per 100,000 people) of Sub-Saharan Africa (developing only) in 1996 to that in 2003?
Ensure brevity in your answer.  0.9. What is the ratio of the Tuberculosis incidents (per 100,000 people) of Uzbekistan in 1996 to that in 2003?
Provide a short and direct response. 0.66. What is the ratio of the Tuberculosis incidents (per 100,000 people) of Sub-Saharan Africa (developing only) in 1997 to that in 1998?
Provide a succinct answer. 0.98. What is the ratio of the Tuberculosis incidents (per 100,000 people) of Sri Lanka in 1997 to that in 1998?
Your answer should be compact. 1. What is the ratio of the Tuberculosis incidents (per 100,000 people) in Uzbekistan in 1997 to that in 1998?
Offer a terse response. 0.94. What is the ratio of the Tuberculosis incidents (per 100,000 people) in Sub-Saharan Africa (developing only) in 1997 to that in 1999?
Your answer should be very brief. 0.96. What is the ratio of the Tuberculosis incidents (per 100,000 people) of Sri Lanka in 1997 to that in 1999?
Keep it short and to the point. 1. What is the ratio of the Tuberculosis incidents (per 100,000 people) of Uzbekistan in 1997 to that in 1999?
Offer a very short reply. 0.88. What is the ratio of the Tuberculosis incidents (per 100,000 people) in Sub-Saharan Africa (developing only) in 1997 to that in 2000?
Your response must be concise. 0.94. What is the ratio of the Tuberculosis incidents (per 100,000 people) in Sri Lanka in 1997 to that in 2000?
Offer a terse response. 1. What is the ratio of the Tuberculosis incidents (per 100,000 people) of Uzbekistan in 1997 to that in 2000?
Provide a succinct answer. 0.82. What is the ratio of the Tuberculosis incidents (per 100,000 people) in Sub-Saharan Africa (developing only) in 1997 to that in 2001?
Offer a very short reply. 0.93. What is the ratio of the Tuberculosis incidents (per 100,000 people) of Uzbekistan in 1997 to that in 2001?
Make the answer very short. 0.76. What is the ratio of the Tuberculosis incidents (per 100,000 people) in Sub-Saharan Africa (developing only) in 1997 to that in 2002?
Provide a succinct answer. 0.92. What is the ratio of the Tuberculosis incidents (per 100,000 people) of Sri Lanka in 1997 to that in 2002?
Make the answer very short. 1. What is the ratio of the Tuberculosis incidents (per 100,000 people) of Uzbekistan in 1997 to that in 2002?
Make the answer very short. 0.72. What is the ratio of the Tuberculosis incidents (per 100,000 people) in Sri Lanka in 1997 to that in 2003?
Provide a succinct answer. 1. What is the ratio of the Tuberculosis incidents (per 100,000 people) in Uzbekistan in 1997 to that in 2003?
Provide a short and direct response. 0.69. What is the ratio of the Tuberculosis incidents (per 100,000 people) of Sub-Saharan Africa (developing only) in 1998 to that in 1999?
Your answer should be very brief. 0.98. What is the ratio of the Tuberculosis incidents (per 100,000 people) in Sri Lanka in 1998 to that in 1999?
Your response must be concise. 1. What is the ratio of the Tuberculosis incidents (per 100,000 people) in Uzbekistan in 1998 to that in 1999?
Your response must be concise. 0.93. What is the ratio of the Tuberculosis incidents (per 100,000 people) in Sub-Saharan Africa (developing only) in 1998 to that in 2000?
Provide a short and direct response. 0.96. What is the ratio of the Tuberculosis incidents (per 100,000 people) of Sri Lanka in 1998 to that in 2000?
Provide a short and direct response. 1. What is the ratio of the Tuberculosis incidents (per 100,000 people) in Uzbekistan in 1998 to that in 2000?
Provide a short and direct response. 0.87. What is the ratio of the Tuberculosis incidents (per 100,000 people) of Sub-Saharan Africa (developing only) in 1998 to that in 2001?
Keep it short and to the point. 0.95. What is the ratio of the Tuberculosis incidents (per 100,000 people) in Sri Lanka in 1998 to that in 2001?
Give a very brief answer. 1. What is the ratio of the Tuberculosis incidents (per 100,000 people) of Uzbekistan in 1998 to that in 2001?
Ensure brevity in your answer.  0.8. What is the ratio of the Tuberculosis incidents (per 100,000 people) in Sub-Saharan Africa (developing only) in 1998 to that in 2002?
Make the answer very short. 0.94. What is the ratio of the Tuberculosis incidents (per 100,000 people) of Uzbekistan in 1998 to that in 2002?
Provide a short and direct response. 0.76. What is the ratio of the Tuberculosis incidents (per 100,000 people) of Sub-Saharan Africa (developing only) in 1998 to that in 2003?
Provide a short and direct response. 0.94. What is the ratio of the Tuberculosis incidents (per 100,000 people) of Uzbekistan in 1998 to that in 2003?
Give a very brief answer. 0.73. What is the ratio of the Tuberculosis incidents (per 100,000 people) of Sub-Saharan Africa (developing only) in 1999 to that in 2000?
Provide a succinct answer. 0.98. What is the ratio of the Tuberculosis incidents (per 100,000 people) in Sri Lanka in 1999 to that in 2000?
Your answer should be very brief. 1. What is the ratio of the Tuberculosis incidents (per 100,000 people) of Uzbekistan in 1999 to that in 2000?
Keep it short and to the point. 0.93. What is the ratio of the Tuberculosis incidents (per 100,000 people) in Sub-Saharan Africa (developing only) in 1999 to that in 2001?
Ensure brevity in your answer.  0.97. What is the ratio of the Tuberculosis incidents (per 100,000 people) of Sri Lanka in 1999 to that in 2001?
Provide a short and direct response. 1. What is the ratio of the Tuberculosis incidents (per 100,000 people) of Uzbekistan in 1999 to that in 2001?
Ensure brevity in your answer.  0.86. What is the ratio of the Tuberculosis incidents (per 100,000 people) of Sub-Saharan Africa (developing only) in 1999 to that in 2002?
Provide a short and direct response. 0.96. What is the ratio of the Tuberculosis incidents (per 100,000 people) in Sri Lanka in 1999 to that in 2002?
Offer a very short reply. 1. What is the ratio of the Tuberculosis incidents (per 100,000 people) of Uzbekistan in 1999 to that in 2002?
Provide a succinct answer. 0.81. What is the ratio of the Tuberculosis incidents (per 100,000 people) of Sub-Saharan Africa (developing only) in 1999 to that in 2003?
Give a very brief answer. 0.96. What is the ratio of the Tuberculosis incidents (per 100,000 people) in Sri Lanka in 1999 to that in 2003?
Ensure brevity in your answer.  1. What is the ratio of the Tuberculosis incidents (per 100,000 people) of Uzbekistan in 1999 to that in 2003?
Keep it short and to the point. 0.79. What is the ratio of the Tuberculosis incidents (per 100,000 people) of Sub-Saharan Africa (developing only) in 2000 to that in 2001?
Keep it short and to the point. 0.99. What is the ratio of the Tuberculosis incidents (per 100,000 people) of Uzbekistan in 2000 to that in 2001?
Your answer should be compact. 0.93. What is the ratio of the Tuberculosis incidents (per 100,000 people) of Sub-Saharan Africa (developing only) in 2000 to that in 2002?
Your response must be concise. 0.98. What is the ratio of the Tuberculosis incidents (per 100,000 people) in Uzbekistan in 2000 to that in 2002?
Your answer should be compact. 0.88. What is the ratio of the Tuberculosis incidents (per 100,000 people) in Uzbekistan in 2000 to that in 2003?
Give a very brief answer. 0.85. What is the ratio of the Tuberculosis incidents (per 100,000 people) in Sri Lanka in 2001 to that in 2002?
Offer a terse response. 1. What is the ratio of the Tuberculosis incidents (per 100,000 people) in Uzbekistan in 2001 to that in 2002?
Give a very brief answer. 0.95. What is the ratio of the Tuberculosis incidents (per 100,000 people) in Sub-Saharan Africa (developing only) in 2001 to that in 2003?
Your response must be concise. 0.99. What is the ratio of the Tuberculosis incidents (per 100,000 people) of Uzbekistan in 2001 to that in 2003?
Offer a very short reply. 0.91. What is the ratio of the Tuberculosis incidents (per 100,000 people) of Sri Lanka in 2002 to that in 2003?
Provide a short and direct response. 1. What is the ratio of the Tuberculosis incidents (per 100,000 people) in Uzbekistan in 2002 to that in 2003?
Offer a very short reply. 0.97. What is the difference between the highest and the second highest Tuberculosis incidents (per 100,000 people) in Uzbekistan?
Provide a succinct answer. 4. What is the difference between the highest and the lowest Tuberculosis incidents (per 100,000 people) in Sub-Saharan Africa (developing only)?
Offer a terse response. 37. 